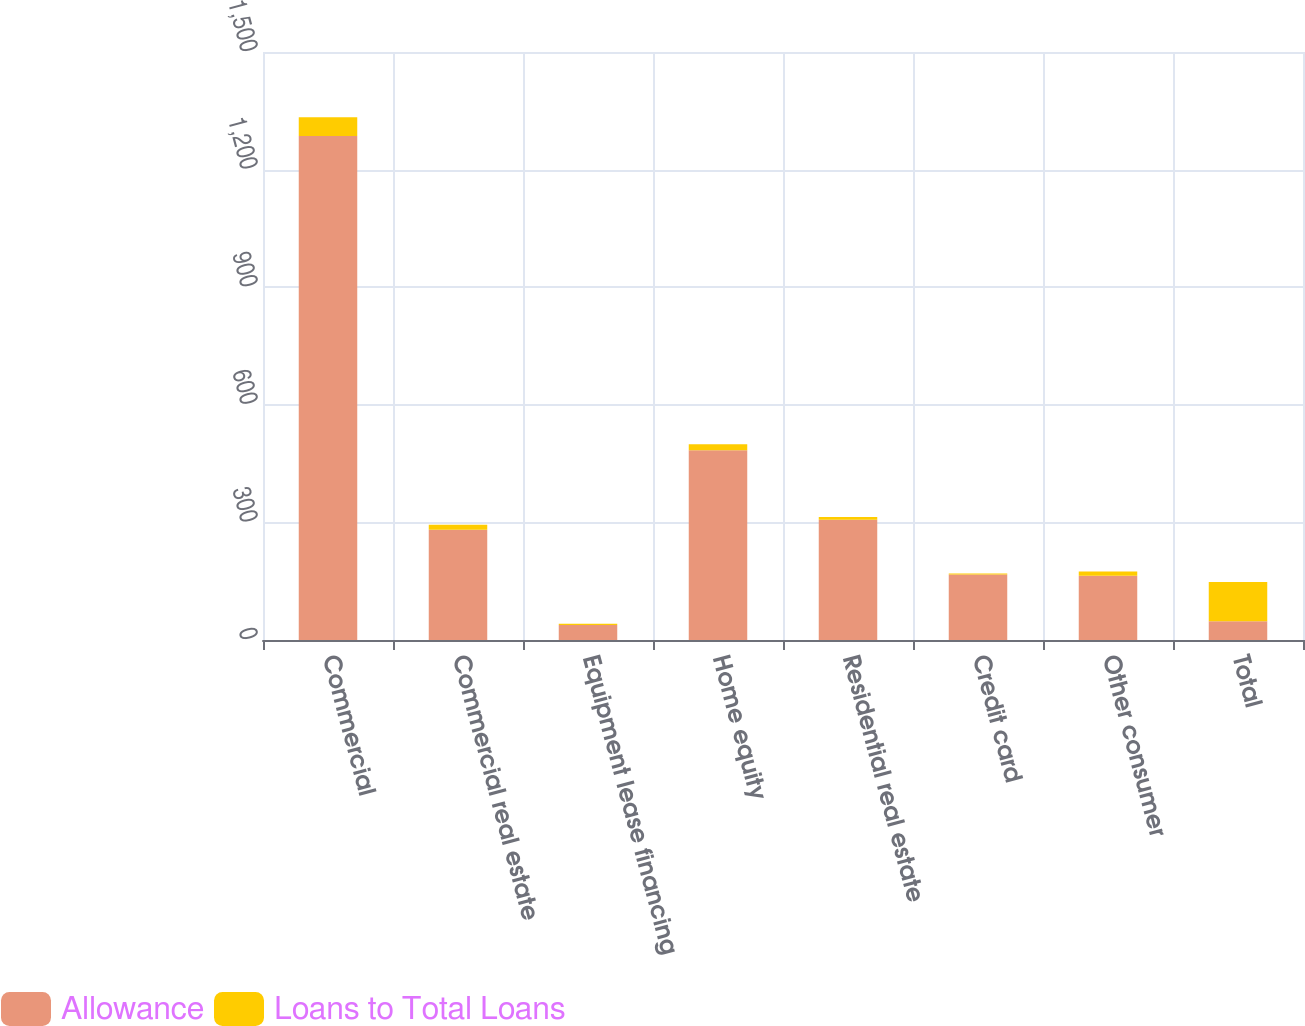Convert chart to OTSL. <chart><loc_0><loc_0><loc_500><loc_500><stacked_bar_chart><ecel><fcel>Commercial<fcel>Commercial real estate<fcel>Equipment lease financing<fcel>Home equity<fcel>Residential real estate<fcel>Credit card<fcel>Other consumer<fcel>Total<nl><fcel>Allowance<fcel>1286<fcel>281<fcel>38<fcel>484<fcel>307<fcel>167<fcel>164<fcel>47.7<nl><fcel>Loans to Total Loans<fcel>47.7<fcel>13.3<fcel>3.6<fcel>15.5<fcel>7<fcel>2.4<fcel>10.5<fcel>100<nl></chart> 